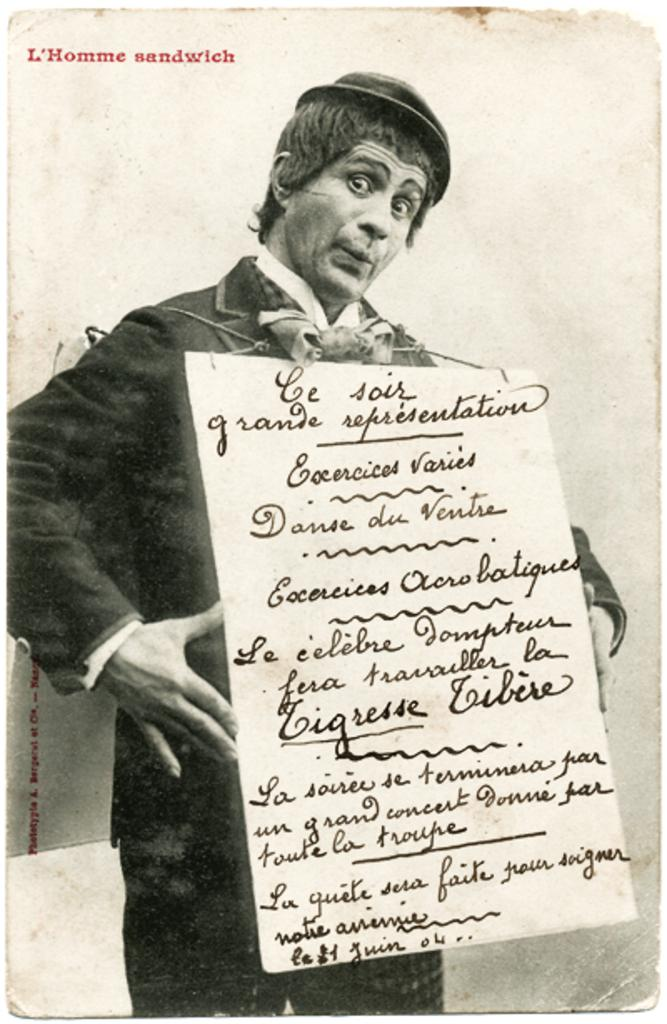What type of picture is in the image? The image contains a black and white picture. Who or what is depicted in the picture? The picture depicts a person. What is the person holding in the picture? The person is holding a board. What can be seen on the board? There is text on the board. What type of roof can be seen on the person in the image? There is no roof present in the image, as it features a person holding a board with text. What kind of magic is the person performing in the image? There is no indication of magic or any magical activity in the image; it simply shows a person holding a board with text. 